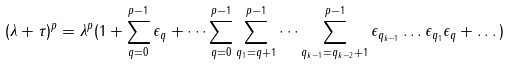Convert formula to latex. <formula><loc_0><loc_0><loc_500><loc_500>\left ( { \lambda + \tau } \right ) ^ { p } = { \lambda } ^ { p } ( 1 + \sum _ { q = 0 } ^ { p - 1 } \epsilon _ { q } + \dots \sum _ { q = 0 } ^ { p - 1 } \sum _ { q _ { 1 } = q + 1 } ^ { p - 1 } \dots \sum _ { q _ { k - 1 } = q _ { k - 2 } + 1 } ^ { p - 1 } \epsilon _ { q _ { k - 1 } } \dots \epsilon _ { q _ { 1 } } \epsilon _ { q } + \dots )</formula> 